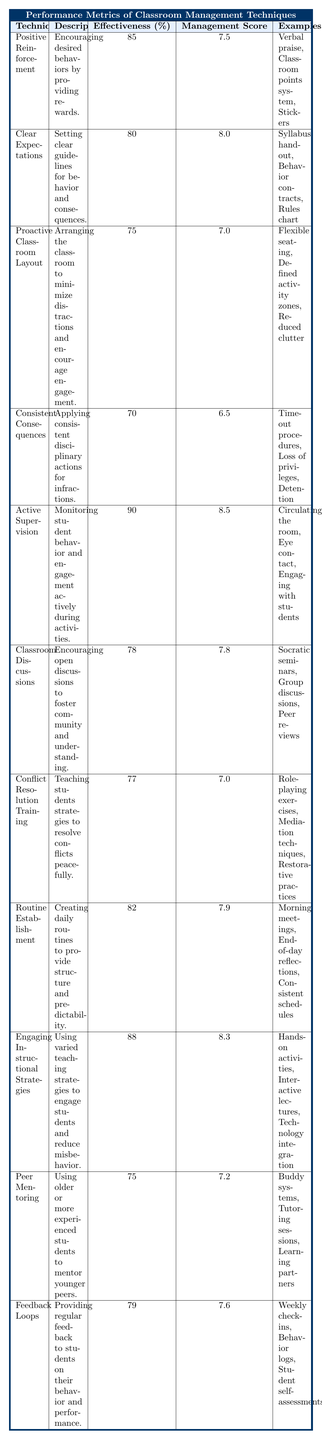What is the effectiveness percentage of Active Supervision? The table shows that the effectiveness percentage for Active Supervision is listed under the "Effectiveness (%)" column. Specifically, it states 90%.
Answer: 90% Which technique has the highest Classroom Management Score? By checking the "Classroom Management Score" column, I can see that Active Supervision has the highest score of 8.5, compared to the other techniques.
Answer: Active Supervision What are the examples provided for Clear Expectations? The table lists the examples for Clear Expectations in the fifth column. It includes "Syllabus handout," "Behavior contracts," and "Rules chart."
Answer: Syllabus handout, Behavior contracts, Rules chart What is the average effectiveness percentage of all techniques listed? To find the average, I will sum all effectiveness percentages: (85 + 80 + 75 + 70 + 90 + 78 + 77 + 82 + 88 + 75 + 79) =  85 + 80 + 75 + 70 + 90 + 78 + 77 + 82 + 88 + 75 + 79 =  885. There are 11 techniques, so the average is 885/11 ≈ 80.5%.
Answer: 80.5% Does Proactive Classroom Layout have a higher effectiveness percentage than Peer Mentoring? I compare the effectiveness percentages provided in the table: Proactive Classroom Layout is 75% and Peer Mentoring is also 75%. Since both percentages are equal, the answer is no.
Answer: No Which technique has an effectiveness percentage lower than 80%? Looking through the effectiveness percentages, I find that Consistent Consequences (70%) and Proactive Classroom Layout (75%) are both below 80%.
Answer: Consistent Consequences, Proactive Classroom Layout If I sum the Classroom Management Scores of techniques above 80% effectiveness, what would it be? The techniques with effectiveness above 80% are: Active Supervision (8.5), Engaging Instructional Strategies (8.3), and Positive Reinforcement (7.5). Adding these scores: 8.5 + 8.3 + 7.5 = 24.3.
Answer: 24.3 Is there a technique that has both high effectiveness and high Classroom Management Score? By reviewing the table, Active Supervision stands out with an effectiveness of 90% and a score of 8.5. Therefore, yes, it fulfills both criteria.
Answer: Yes What is the difference between the effectiveness percentage of Engaging Instructional Strategies and Classroom Discussions? Engaging Instructional Strategies has an effectiveness rate of 88% and Classroom Discussions has 78%. The difference is calculated as 88 - 78 = 10%.
Answer: 10% Which technique teaches strategies to resolve conflicts peacefully? The description for Conflict Resolution Training specifically states it teaches strategies to resolve conflicts peacefully, as seen in the "Description" column.
Answer: Conflict Resolution Training 